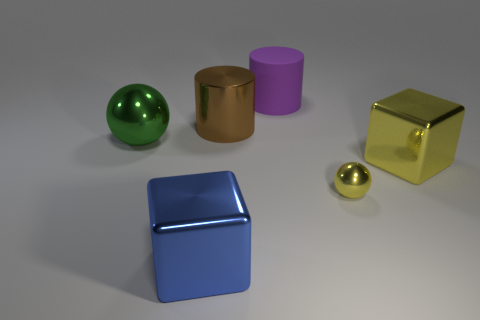Subtract 1 blocks. How many blocks are left? 1 Add 2 large cylinders. How many objects exist? 8 Subtract all green balls. How many balls are left? 1 Subtract 0 red cubes. How many objects are left? 6 Subtract all brown spheres. Subtract all green cylinders. How many spheres are left? 2 Subtract all red rubber objects. Subtract all large green objects. How many objects are left? 5 Add 2 yellow objects. How many yellow objects are left? 4 Add 3 large purple rubber cylinders. How many large purple rubber cylinders exist? 4 